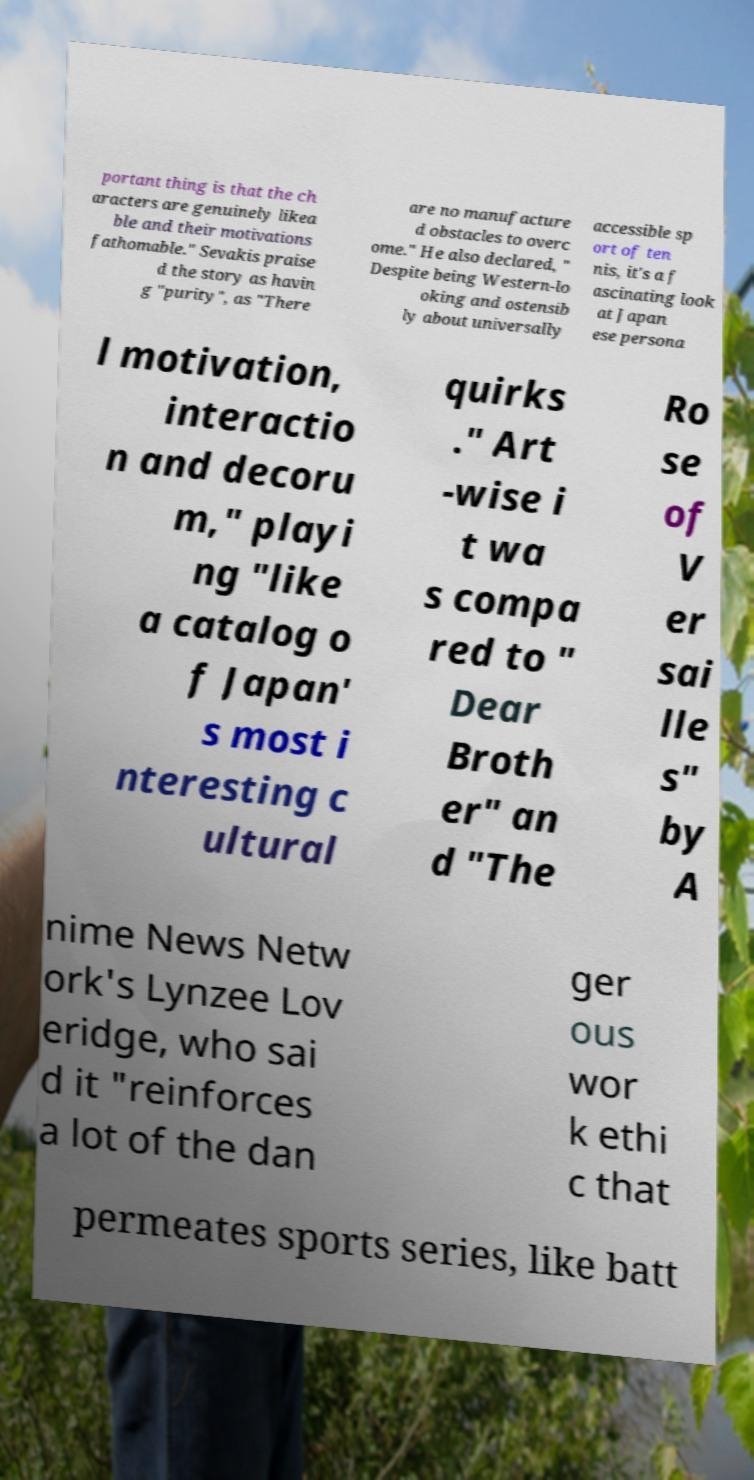Can you read and provide the text displayed in the image?This photo seems to have some interesting text. Can you extract and type it out for me? portant thing is that the ch aracters are genuinely likea ble and their motivations fathomable." Sevakis praise d the story as havin g "purity", as "There are no manufacture d obstacles to overc ome." He also declared, " Despite being Western-lo oking and ostensib ly about universally accessible sp ort of ten nis, it's a f ascinating look at Japan ese persona l motivation, interactio n and decoru m," playi ng "like a catalog o f Japan' s most i nteresting c ultural quirks ." Art -wise i t wa s compa red to " Dear Broth er" an d "The Ro se of V er sai lle s" by A nime News Netw ork's Lynzee Lov eridge, who sai d it "reinforces a lot of the dan ger ous wor k ethi c that permeates sports series, like batt 